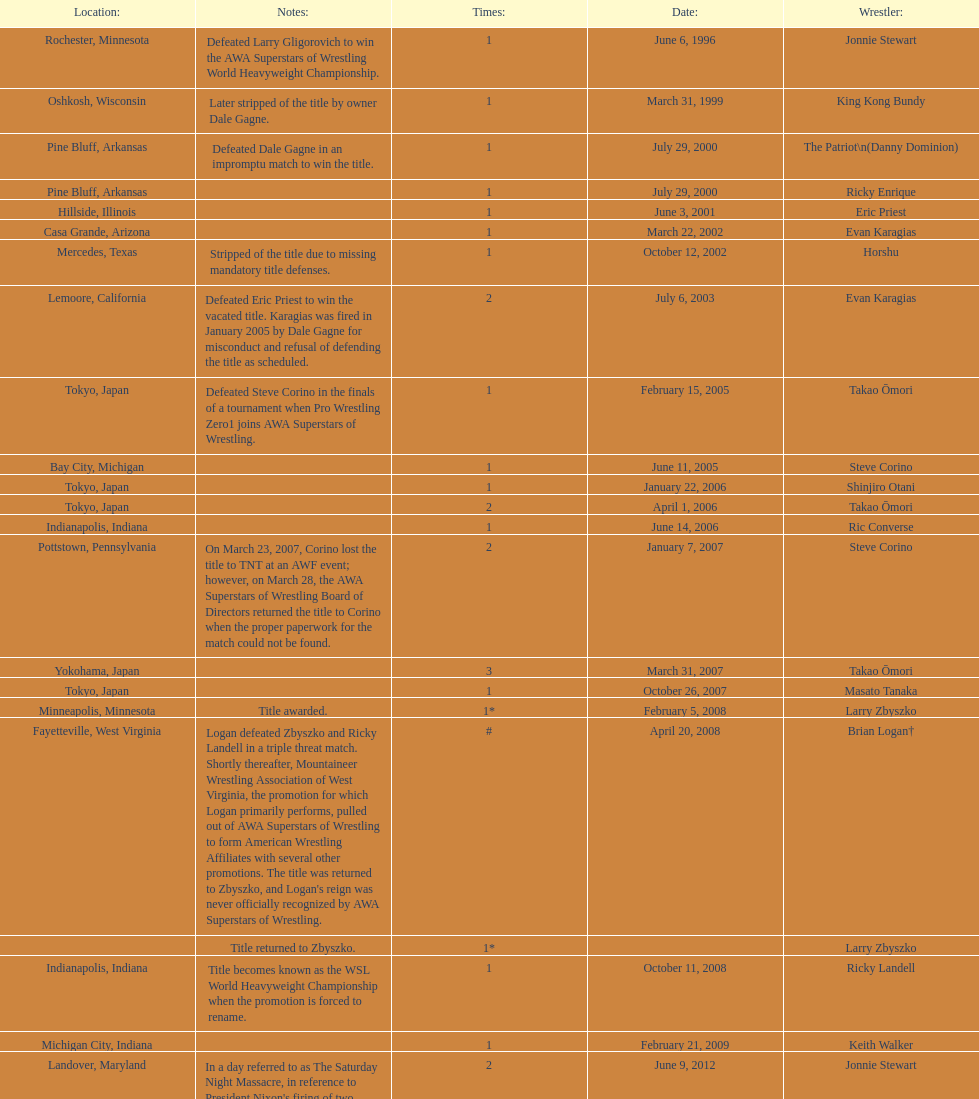Can you give me this table as a dict? {'header': ['Location:', 'Notes:', 'Times:', 'Date:', 'Wrestler:'], 'rows': [['Rochester, Minnesota', 'Defeated Larry Gligorovich to win the AWA Superstars of Wrestling World Heavyweight Championship.', '1', 'June 6, 1996', 'Jonnie Stewart'], ['Oshkosh, Wisconsin', 'Later stripped of the title by owner Dale Gagne.', '1', 'March 31, 1999', 'King Kong Bundy'], ['Pine Bluff, Arkansas', 'Defeated Dale Gagne in an impromptu match to win the title.', '1', 'July 29, 2000', 'The Patriot\\n(Danny Dominion)'], ['Pine Bluff, Arkansas', '', '1', 'July 29, 2000', 'Ricky Enrique'], ['Hillside, Illinois', '', '1', 'June 3, 2001', 'Eric Priest'], ['Casa Grande, Arizona', '', '1', 'March 22, 2002', 'Evan Karagias'], ['Mercedes, Texas', 'Stripped of the title due to missing mandatory title defenses.', '1', 'October 12, 2002', 'Horshu'], ['Lemoore, California', 'Defeated Eric Priest to win the vacated title. Karagias was fired in January 2005 by Dale Gagne for misconduct and refusal of defending the title as scheduled.', '2', 'July 6, 2003', 'Evan Karagias'], ['Tokyo, Japan', 'Defeated Steve Corino in the finals of a tournament when Pro Wrestling Zero1 joins AWA Superstars of Wrestling.', '1', 'February 15, 2005', 'Takao Ōmori'], ['Bay City, Michigan', '', '1', 'June 11, 2005', 'Steve Corino'], ['Tokyo, Japan', '', '1', 'January 22, 2006', 'Shinjiro Otani'], ['Tokyo, Japan', '', '2', 'April 1, 2006', 'Takao Ōmori'], ['Indianapolis, Indiana', '', '1', 'June 14, 2006', 'Ric Converse'], ['Pottstown, Pennsylvania', 'On March 23, 2007, Corino lost the title to TNT at an AWF event; however, on March 28, the AWA Superstars of Wrestling Board of Directors returned the title to Corino when the proper paperwork for the match could not be found.', '2', 'January 7, 2007', 'Steve Corino'], ['Yokohama, Japan', '', '3', 'March 31, 2007', 'Takao Ōmori'], ['Tokyo, Japan', '', '1', 'October 26, 2007', 'Masato Tanaka'], ['Minneapolis, Minnesota', 'Title awarded.', '1*', 'February 5, 2008', 'Larry Zbyszko'], ['Fayetteville, West Virginia', "Logan defeated Zbyszko and Ricky Landell in a triple threat match. Shortly thereafter, Mountaineer Wrestling Association of West Virginia, the promotion for which Logan primarily performs, pulled out of AWA Superstars of Wrestling to form American Wrestling Affiliates with several other promotions. The title was returned to Zbyszko, and Logan's reign was never officially recognized by AWA Superstars of Wrestling.", '#', 'April 20, 2008', 'Brian Logan†'], ['', 'Title returned to Zbyszko.', '1*', '', 'Larry Zbyszko'], ['Indianapolis, Indiana', 'Title becomes known as the WSL World Heavyweight Championship when the promotion is forced to rename.', '1', 'October 11, 2008', 'Ricky Landell'], ['Michigan City, Indiana', '', '1', 'February 21, 2009', 'Keith Walker'], ['Landover, Maryland', "In a day referred to as The Saturday Night Massacre, in reference to President Nixon's firing of two Whitehouse attorneys general in one night; President Dale Gagne strips and fires Keith Walker when Walker refuses to defend the title against Ricky Landell, in an event in Landover, Maryland. When Landell is awarded the title, he refuses to accept and is too promptly fired by Gagne, who than awards the title to Jonnie Stewart.", '2', 'June 9, 2012', 'Jonnie Stewart'], ['Rockford, Illinois', "The morning of the event, Jonnie Stewart's doctors declare him PUP (physically unable to perform) and WSL officials agree to let Mike Bally sub for Stewart.", '1', 'August 18, 2012', 'The Honky Tonk Man']]} Who is listed before keith walker? Ricky Landell. 